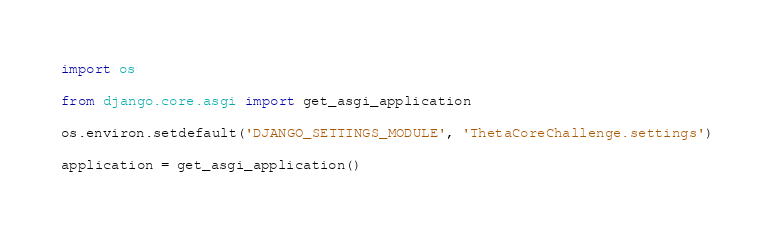<code> <loc_0><loc_0><loc_500><loc_500><_Python_>
import os

from django.core.asgi import get_asgi_application

os.environ.setdefault('DJANGO_SETTINGS_MODULE', 'ThetaCoreChallenge.settings')

application = get_asgi_application()
</code> 